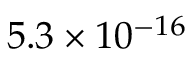Convert formula to latex. <formula><loc_0><loc_0><loc_500><loc_500>5 . 3 \times 1 0 ^ { - 1 6 }</formula> 